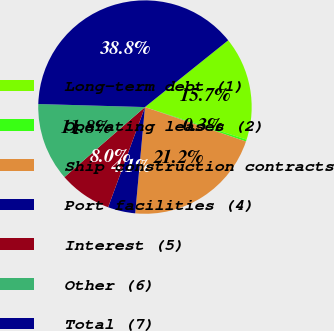Convert chart. <chart><loc_0><loc_0><loc_500><loc_500><pie_chart><fcel>Long-term debt (1)<fcel>Operating leases (2)<fcel>Ship construction contracts<fcel>Port facilities (4)<fcel>Interest (5)<fcel>Other (6)<fcel>Total (7)<nl><fcel>15.69%<fcel>0.3%<fcel>21.23%<fcel>4.15%<fcel>8.0%<fcel>11.85%<fcel>38.79%<nl></chart> 